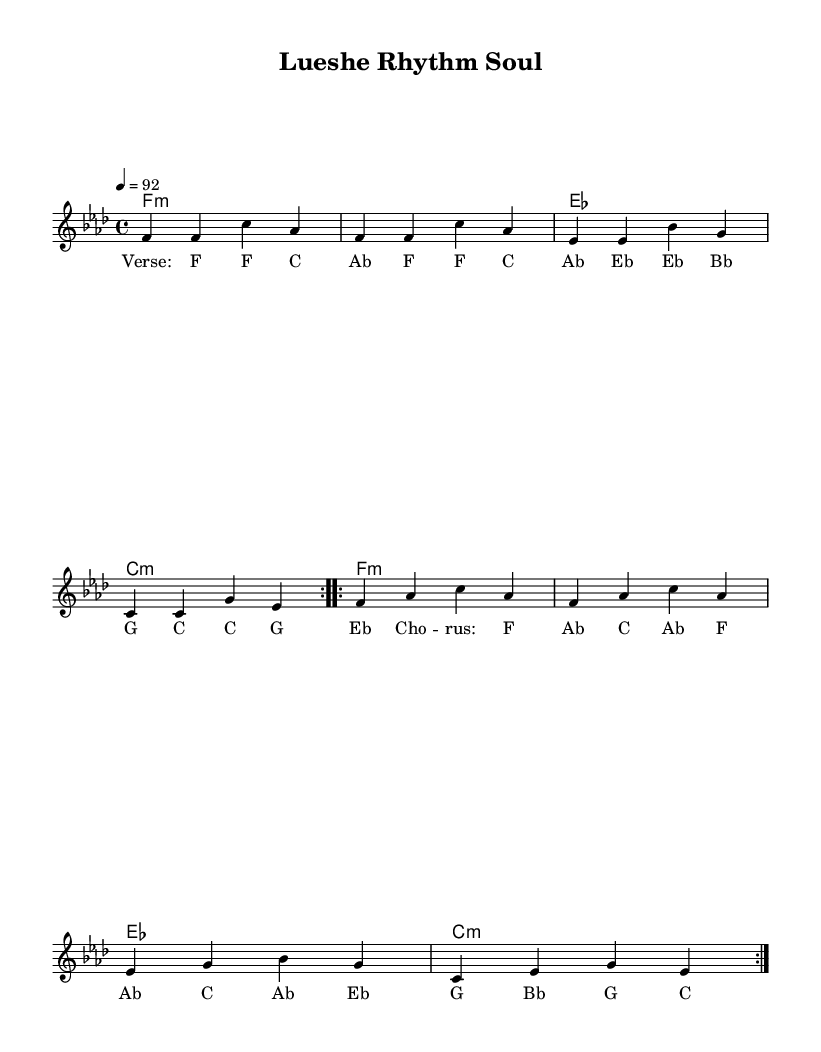What is the key signature of this music? The key signature is F minor, which has four flats (B, E, A, and D). This can be identified at the beginning of the staff, where the flats are placed.
Answer: F minor What is the time signature of this music? The time signature is 4/4, which indicates there are four beats in each measure. This is shown at the beginning of the score, directly following the key signature.
Answer: 4/4 What is the tempo indicated in the music? The tempo is marked as quarter note equals 92, which specifies the speed of the music. This is communicated in the tempo marking at the beginning of the score.
Answer: 92 How many measures are repeated in the melody section? The melody sections are marked to be repeated twice, indicated by the volta signs that are present in the melody.
Answer: 2 What is the first chord in the harmonies? The first chord in the harmonies is F minor, noted as "f1:m" at the beginning of the harmony section. This is the first chord listed and sets the tone for the piece.
Answer: F minor What is the structure of the lyrics in this piece? The lyrics are structured in verses and choruses, as indicated by labels "Verse" and "Chorus" before the lyrical phrases. This shows the organization of the song into distinct sections Vocally.
Answer: Verse and Chorus How do the rhythms from Congolese music influence this piece? The piece blends Congolese rhythms by incorporating syncopated patterns typically found in African music, contributing to the overall feel of the soulful fusion. This is recognized through the rhythmic motif and style that aligns with traditional Congolese music.
Answer: Syncopated rhythms 